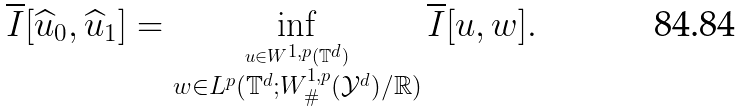Convert formula to latex. <formula><loc_0><loc_0><loc_500><loc_500>\overline { I } [ \widehat { u } _ { 0 } , \widehat { u } _ { 1 } ] = \inf _ { \overset { u \in W ^ { 1 , p } ( \mathbb { T } ^ { d } ) } { w \in L ^ { p } ( \mathbb { T } ^ { d } ; W ^ { 1 , p } _ { \# } ( \mathcal { Y } ^ { d } ) / \mathbb { R } ) } } \overline { I } [ u , w ] .</formula> 